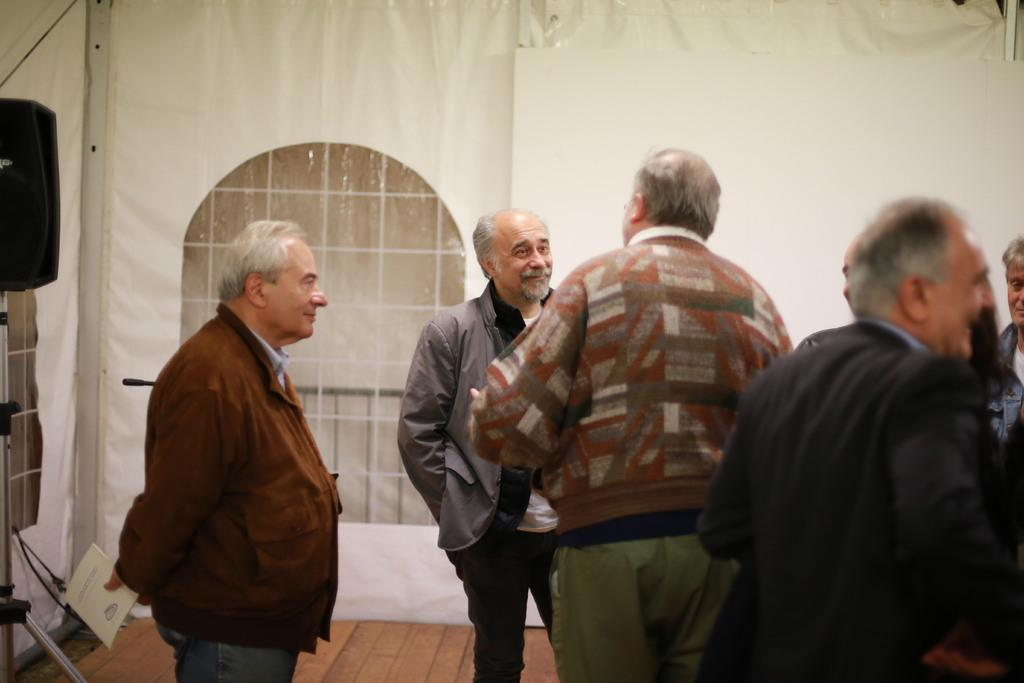What are the people in the image wearing? The persons in the image are wearing clothes. What can be seen in the middle of the image? There is a window in the middle of the image. Where is the person located in the image? There is a person at the bottom of the image. What is the person at the bottom of the image doing? The person at the bottom of the image is holding a book with his hand. What type of value is being exchanged between the persons in the image? There is no indication of any value exchange between the persons in the image. What is the person at the bottom of the image eating for breakfast? There is no information about breakfast in the image, and the person at the bottom of the image is holding a book, not eating. 